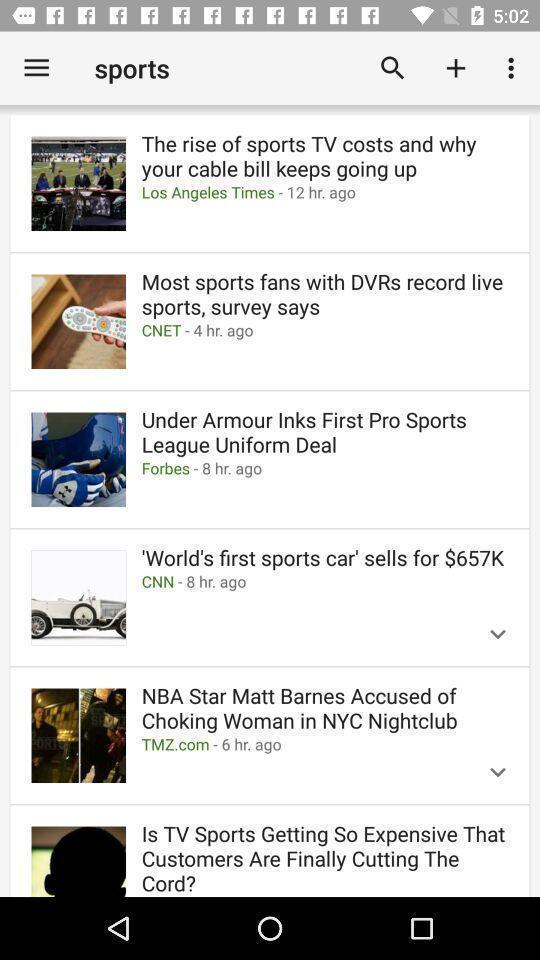Provide a description of this screenshot. Search page for searching information of sports. 